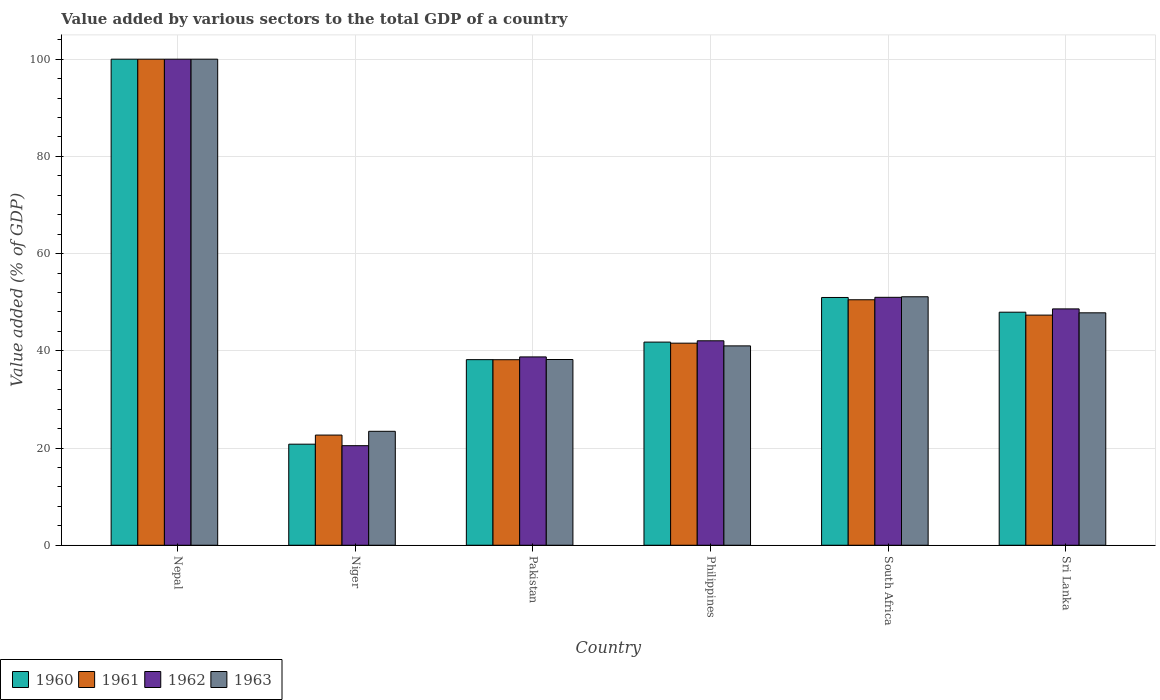What is the label of the 2nd group of bars from the left?
Your response must be concise. Niger. In how many cases, is the number of bars for a given country not equal to the number of legend labels?
Your answer should be very brief. 0. What is the value added by various sectors to the total GDP in 1961 in Philippines?
Offer a terse response. 41.57. Across all countries, what is the minimum value added by various sectors to the total GDP in 1962?
Make the answer very short. 20.48. In which country was the value added by various sectors to the total GDP in 1962 maximum?
Provide a succinct answer. Nepal. In which country was the value added by various sectors to the total GDP in 1960 minimum?
Your response must be concise. Niger. What is the total value added by various sectors to the total GDP in 1962 in the graph?
Provide a succinct answer. 300.92. What is the difference between the value added by various sectors to the total GDP in 1962 in South Africa and that in Sri Lanka?
Provide a succinct answer. 2.38. What is the difference between the value added by various sectors to the total GDP in 1963 in South Africa and the value added by various sectors to the total GDP in 1962 in Niger?
Ensure brevity in your answer.  30.63. What is the average value added by various sectors to the total GDP in 1961 per country?
Ensure brevity in your answer.  50.04. What is the difference between the value added by various sectors to the total GDP of/in 1963 and value added by various sectors to the total GDP of/in 1961 in Pakistan?
Your response must be concise. 0.04. In how many countries, is the value added by various sectors to the total GDP in 1963 greater than 40 %?
Offer a very short reply. 4. What is the ratio of the value added by various sectors to the total GDP in 1961 in Nepal to that in Pakistan?
Ensure brevity in your answer.  2.62. What is the difference between the highest and the second highest value added by various sectors to the total GDP in 1962?
Offer a terse response. -2.38. What is the difference between the highest and the lowest value added by various sectors to the total GDP in 1961?
Provide a succinct answer. 77.33. In how many countries, is the value added by various sectors to the total GDP in 1962 greater than the average value added by various sectors to the total GDP in 1962 taken over all countries?
Make the answer very short. 2. Is the sum of the value added by various sectors to the total GDP in 1963 in Niger and Pakistan greater than the maximum value added by various sectors to the total GDP in 1961 across all countries?
Make the answer very short. No. What does the 4th bar from the left in Niger represents?
Ensure brevity in your answer.  1963. Is it the case that in every country, the sum of the value added by various sectors to the total GDP in 1962 and value added by various sectors to the total GDP in 1963 is greater than the value added by various sectors to the total GDP in 1960?
Offer a terse response. Yes. How many countries are there in the graph?
Offer a terse response. 6. What is the difference between two consecutive major ticks on the Y-axis?
Offer a terse response. 20. Does the graph contain grids?
Make the answer very short. Yes. Where does the legend appear in the graph?
Your answer should be compact. Bottom left. How many legend labels are there?
Provide a succinct answer. 4. How are the legend labels stacked?
Your response must be concise. Horizontal. What is the title of the graph?
Offer a very short reply. Value added by various sectors to the total GDP of a country. Does "1963" appear as one of the legend labels in the graph?
Provide a succinct answer. Yes. What is the label or title of the X-axis?
Your answer should be very brief. Country. What is the label or title of the Y-axis?
Your answer should be compact. Value added (% of GDP). What is the Value added (% of GDP) of 1960 in Nepal?
Offer a very short reply. 100. What is the Value added (% of GDP) of 1962 in Nepal?
Your response must be concise. 100. What is the Value added (% of GDP) in 1963 in Nepal?
Your response must be concise. 100. What is the Value added (% of GDP) of 1960 in Niger?
Your answer should be compact. 20.79. What is the Value added (% of GDP) in 1961 in Niger?
Provide a succinct answer. 22.67. What is the Value added (% of GDP) in 1962 in Niger?
Provide a succinct answer. 20.48. What is the Value added (% of GDP) in 1963 in Niger?
Offer a very short reply. 23.44. What is the Value added (% of GDP) of 1960 in Pakistan?
Make the answer very short. 38.18. What is the Value added (% of GDP) of 1961 in Pakistan?
Your answer should be compact. 38.17. What is the Value added (% of GDP) in 1962 in Pakistan?
Your answer should be very brief. 38.74. What is the Value added (% of GDP) in 1963 in Pakistan?
Provide a short and direct response. 38.21. What is the Value added (% of GDP) in 1960 in Philippines?
Make the answer very short. 41.79. What is the Value added (% of GDP) in 1961 in Philippines?
Your answer should be compact. 41.57. What is the Value added (% of GDP) of 1962 in Philippines?
Provide a short and direct response. 42.06. What is the Value added (% of GDP) of 1963 in Philippines?
Keep it short and to the point. 41.01. What is the Value added (% of GDP) in 1960 in South Africa?
Make the answer very short. 50.97. What is the Value added (% of GDP) of 1961 in South Africa?
Give a very brief answer. 50.5. What is the Value added (% of GDP) in 1962 in South Africa?
Give a very brief answer. 51.01. What is the Value added (% of GDP) of 1963 in South Africa?
Your answer should be compact. 51.12. What is the Value added (% of GDP) in 1960 in Sri Lanka?
Provide a short and direct response. 47.95. What is the Value added (% of GDP) of 1961 in Sri Lanka?
Ensure brevity in your answer.  47.35. What is the Value added (% of GDP) in 1962 in Sri Lanka?
Your response must be concise. 48.62. What is the Value added (% of GDP) of 1963 in Sri Lanka?
Ensure brevity in your answer.  47.82. Across all countries, what is the minimum Value added (% of GDP) in 1960?
Your answer should be compact. 20.79. Across all countries, what is the minimum Value added (% of GDP) in 1961?
Offer a very short reply. 22.67. Across all countries, what is the minimum Value added (% of GDP) of 1962?
Provide a succinct answer. 20.48. Across all countries, what is the minimum Value added (% of GDP) of 1963?
Offer a terse response. 23.44. What is the total Value added (% of GDP) in 1960 in the graph?
Offer a very short reply. 299.68. What is the total Value added (% of GDP) of 1961 in the graph?
Ensure brevity in your answer.  300.26. What is the total Value added (% of GDP) of 1962 in the graph?
Give a very brief answer. 300.92. What is the total Value added (% of GDP) of 1963 in the graph?
Give a very brief answer. 301.6. What is the difference between the Value added (% of GDP) in 1960 in Nepal and that in Niger?
Give a very brief answer. 79.21. What is the difference between the Value added (% of GDP) in 1961 in Nepal and that in Niger?
Offer a terse response. 77.33. What is the difference between the Value added (% of GDP) of 1962 in Nepal and that in Niger?
Your response must be concise. 79.52. What is the difference between the Value added (% of GDP) of 1963 in Nepal and that in Niger?
Your answer should be compact. 76.56. What is the difference between the Value added (% of GDP) of 1960 in Nepal and that in Pakistan?
Provide a succinct answer. 61.82. What is the difference between the Value added (% of GDP) of 1961 in Nepal and that in Pakistan?
Offer a very short reply. 61.83. What is the difference between the Value added (% of GDP) in 1962 in Nepal and that in Pakistan?
Give a very brief answer. 61.26. What is the difference between the Value added (% of GDP) of 1963 in Nepal and that in Pakistan?
Your answer should be compact. 61.79. What is the difference between the Value added (% of GDP) of 1960 in Nepal and that in Philippines?
Offer a terse response. 58.21. What is the difference between the Value added (% of GDP) of 1961 in Nepal and that in Philippines?
Make the answer very short. 58.42. What is the difference between the Value added (% of GDP) in 1962 in Nepal and that in Philippines?
Provide a succinct answer. 57.94. What is the difference between the Value added (% of GDP) of 1963 in Nepal and that in Philippines?
Make the answer very short. 58.99. What is the difference between the Value added (% of GDP) of 1960 in Nepal and that in South Africa?
Your answer should be compact. 49.03. What is the difference between the Value added (% of GDP) of 1961 in Nepal and that in South Africa?
Your answer should be very brief. 49.5. What is the difference between the Value added (% of GDP) in 1962 in Nepal and that in South Africa?
Ensure brevity in your answer.  48.99. What is the difference between the Value added (% of GDP) in 1963 in Nepal and that in South Africa?
Keep it short and to the point. 48.88. What is the difference between the Value added (% of GDP) in 1960 in Nepal and that in Sri Lanka?
Provide a short and direct response. 52.05. What is the difference between the Value added (% of GDP) of 1961 in Nepal and that in Sri Lanka?
Your response must be concise. 52.65. What is the difference between the Value added (% of GDP) in 1962 in Nepal and that in Sri Lanka?
Your response must be concise. 51.38. What is the difference between the Value added (% of GDP) of 1963 in Nepal and that in Sri Lanka?
Give a very brief answer. 52.18. What is the difference between the Value added (% of GDP) of 1960 in Niger and that in Pakistan?
Offer a very short reply. -17.39. What is the difference between the Value added (% of GDP) of 1961 in Niger and that in Pakistan?
Your response must be concise. -15.5. What is the difference between the Value added (% of GDP) in 1962 in Niger and that in Pakistan?
Your answer should be very brief. -18.26. What is the difference between the Value added (% of GDP) of 1963 in Niger and that in Pakistan?
Your answer should be very brief. -14.77. What is the difference between the Value added (% of GDP) in 1960 in Niger and that in Philippines?
Offer a terse response. -21. What is the difference between the Value added (% of GDP) of 1961 in Niger and that in Philippines?
Make the answer very short. -18.91. What is the difference between the Value added (% of GDP) in 1962 in Niger and that in Philippines?
Provide a short and direct response. -21.58. What is the difference between the Value added (% of GDP) in 1963 in Niger and that in Philippines?
Your response must be concise. -17.58. What is the difference between the Value added (% of GDP) in 1960 in Niger and that in South Africa?
Provide a short and direct response. -30.18. What is the difference between the Value added (% of GDP) in 1961 in Niger and that in South Africa?
Make the answer very short. -27.84. What is the difference between the Value added (% of GDP) in 1962 in Niger and that in South Africa?
Keep it short and to the point. -30.52. What is the difference between the Value added (% of GDP) in 1963 in Niger and that in South Africa?
Your response must be concise. -27.68. What is the difference between the Value added (% of GDP) in 1960 in Niger and that in Sri Lanka?
Ensure brevity in your answer.  -27.16. What is the difference between the Value added (% of GDP) of 1961 in Niger and that in Sri Lanka?
Provide a succinct answer. -24.68. What is the difference between the Value added (% of GDP) in 1962 in Niger and that in Sri Lanka?
Offer a very short reply. -28.14. What is the difference between the Value added (% of GDP) in 1963 in Niger and that in Sri Lanka?
Your response must be concise. -24.38. What is the difference between the Value added (% of GDP) in 1960 in Pakistan and that in Philippines?
Keep it short and to the point. -3.61. What is the difference between the Value added (% of GDP) in 1961 in Pakistan and that in Philippines?
Your response must be concise. -3.41. What is the difference between the Value added (% of GDP) of 1962 in Pakistan and that in Philippines?
Give a very brief answer. -3.32. What is the difference between the Value added (% of GDP) of 1963 in Pakistan and that in Philippines?
Provide a succinct answer. -2.81. What is the difference between the Value added (% of GDP) in 1960 in Pakistan and that in South Africa?
Provide a short and direct response. -12.79. What is the difference between the Value added (% of GDP) of 1961 in Pakistan and that in South Africa?
Your answer should be very brief. -12.33. What is the difference between the Value added (% of GDP) in 1962 in Pakistan and that in South Africa?
Ensure brevity in your answer.  -12.26. What is the difference between the Value added (% of GDP) in 1963 in Pakistan and that in South Africa?
Provide a short and direct response. -12.91. What is the difference between the Value added (% of GDP) of 1960 in Pakistan and that in Sri Lanka?
Keep it short and to the point. -9.76. What is the difference between the Value added (% of GDP) of 1961 in Pakistan and that in Sri Lanka?
Your answer should be compact. -9.18. What is the difference between the Value added (% of GDP) of 1962 in Pakistan and that in Sri Lanka?
Give a very brief answer. -9.88. What is the difference between the Value added (% of GDP) in 1963 in Pakistan and that in Sri Lanka?
Your response must be concise. -9.61. What is the difference between the Value added (% of GDP) in 1960 in Philippines and that in South Africa?
Offer a very short reply. -9.18. What is the difference between the Value added (% of GDP) in 1961 in Philippines and that in South Africa?
Make the answer very short. -8.93. What is the difference between the Value added (% of GDP) in 1962 in Philippines and that in South Africa?
Offer a very short reply. -8.94. What is the difference between the Value added (% of GDP) of 1963 in Philippines and that in South Africa?
Provide a short and direct response. -10.1. What is the difference between the Value added (% of GDP) of 1960 in Philippines and that in Sri Lanka?
Provide a succinct answer. -6.15. What is the difference between the Value added (% of GDP) of 1961 in Philippines and that in Sri Lanka?
Give a very brief answer. -5.77. What is the difference between the Value added (% of GDP) of 1962 in Philippines and that in Sri Lanka?
Make the answer very short. -6.56. What is the difference between the Value added (% of GDP) of 1963 in Philippines and that in Sri Lanka?
Provide a succinct answer. -6.8. What is the difference between the Value added (% of GDP) of 1960 in South Africa and that in Sri Lanka?
Ensure brevity in your answer.  3.03. What is the difference between the Value added (% of GDP) of 1961 in South Africa and that in Sri Lanka?
Give a very brief answer. 3.16. What is the difference between the Value added (% of GDP) in 1962 in South Africa and that in Sri Lanka?
Keep it short and to the point. 2.38. What is the difference between the Value added (% of GDP) in 1963 in South Africa and that in Sri Lanka?
Your answer should be compact. 3.3. What is the difference between the Value added (% of GDP) in 1960 in Nepal and the Value added (% of GDP) in 1961 in Niger?
Give a very brief answer. 77.33. What is the difference between the Value added (% of GDP) of 1960 in Nepal and the Value added (% of GDP) of 1962 in Niger?
Offer a terse response. 79.52. What is the difference between the Value added (% of GDP) in 1960 in Nepal and the Value added (% of GDP) in 1963 in Niger?
Ensure brevity in your answer.  76.56. What is the difference between the Value added (% of GDP) in 1961 in Nepal and the Value added (% of GDP) in 1962 in Niger?
Provide a short and direct response. 79.52. What is the difference between the Value added (% of GDP) in 1961 in Nepal and the Value added (% of GDP) in 1963 in Niger?
Provide a short and direct response. 76.56. What is the difference between the Value added (% of GDP) in 1962 in Nepal and the Value added (% of GDP) in 1963 in Niger?
Give a very brief answer. 76.56. What is the difference between the Value added (% of GDP) of 1960 in Nepal and the Value added (% of GDP) of 1961 in Pakistan?
Offer a very short reply. 61.83. What is the difference between the Value added (% of GDP) in 1960 in Nepal and the Value added (% of GDP) in 1962 in Pakistan?
Offer a terse response. 61.26. What is the difference between the Value added (% of GDP) in 1960 in Nepal and the Value added (% of GDP) in 1963 in Pakistan?
Make the answer very short. 61.79. What is the difference between the Value added (% of GDP) in 1961 in Nepal and the Value added (% of GDP) in 1962 in Pakistan?
Ensure brevity in your answer.  61.26. What is the difference between the Value added (% of GDP) in 1961 in Nepal and the Value added (% of GDP) in 1963 in Pakistan?
Provide a short and direct response. 61.79. What is the difference between the Value added (% of GDP) of 1962 in Nepal and the Value added (% of GDP) of 1963 in Pakistan?
Your answer should be very brief. 61.79. What is the difference between the Value added (% of GDP) in 1960 in Nepal and the Value added (% of GDP) in 1961 in Philippines?
Provide a succinct answer. 58.42. What is the difference between the Value added (% of GDP) of 1960 in Nepal and the Value added (% of GDP) of 1962 in Philippines?
Make the answer very short. 57.94. What is the difference between the Value added (% of GDP) of 1960 in Nepal and the Value added (% of GDP) of 1963 in Philippines?
Your answer should be compact. 58.99. What is the difference between the Value added (% of GDP) of 1961 in Nepal and the Value added (% of GDP) of 1962 in Philippines?
Offer a very short reply. 57.94. What is the difference between the Value added (% of GDP) in 1961 in Nepal and the Value added (% of GDP) in 1963 in Philippines?
Offer a very short reply. 58.99. What is the difference between the Value added (% of GDP) in 1962 in Nepal and the Value added (% of GDP) in 1963 in Philippines?
Keep it short and to the point. 58.99. What is the difference between the Value added (% of GDP) in 1960 in Nepal and the Value added (% of GDP) in 1961 in South Africa?
Your answer should be compact. 49.5. What is the difference between the Value added (% of GDP) of 1960 in Nepal and the Value added (% of GDP) of 1962 in South Africa?
Make the answer very short. 48.99. What is the difference between the Value added (% of GDP) in 1960 in Nepal and the Value added (% of GDP) in 1963 in South Africa?
Your response must be concise. 48.88. What is the difference between the Value added (% of GDP) of 1961 in Nepal and the Value added (% of GDP) of 1962 in South Africa?
Offer a very short reply. 48.99. What is the difference between the Value added (% of GDP) of 1961 in Nepal and the Value added (% of GDP) of 1963 in South Africa?
Make the answer very short. 48.88. What is the difference between the Value added (% of GDP) of 1962 in Nepal and the Value added (% of GDP) of 1963 in South Africa?
Give a very brief answer. 48.88. What is the difference between the Value added (% of GDP) of 1960 in Nepal and the Value added (% of GDP) of 1961 in Sri Lanka?
Your answer should be compact. 52.65. What is the difference between the Value added (% of GDP) in 1960 in Nepal and the Value added (% of GDP) in 1962 in Sri Lanka?
Your answer should be very brief. 51.38. What is the difference between the Value added (% of GDP) in 1960 in Nepal and the Value added (% of GDP) in 1963 in Sri Lanka?
Your answer should be compact. 52.18. What is the difference between the Value added (% of GDP) in 1961 in Nepal and the Value added (% of GDP) in 1962 in Sri Lanka?
Provide a short and direct response. 51.38. What is the difference between the Value added (% of GDP) of 1961 in Nepal and the Value added (% of GDP) of 1963 in Sri Lanka?
Provide a short and direct response. 52.18. What is the difference between the Value added (% of GDP) of 1962 in Nepal and the Value added (% of GDP) of 1963 in Sri Lanka?
Make the answer very short. 52.18. What is the difference between the Value added (% of GDP) of 1960 in Niger and the Value added (% of GDP) of 1961 in Pakistan?
Provide a succinct answer. -17.38. What is the difference between the Value added (% of GDP) of 1960 in Niger and the Value added (% of GDP) of 1962 in Pakistan?
Provide a succinct answer. -17.95. What is the difference between the Value added (% of GDP) in 1960 in Niger and the Value added (% of GDP) in 1963 in Pakistan?
Offer a very short reply. -17.42. What is the difference between the Value added (% of GDP) in 1961 in Niger and the Value added (% of GDP) in 1962 in Pakistan?
Provide a short and direct response. -16.08. What is the difference between the Value added (% of GDP) of 1961 in Niger and the Value added (% of GDP) of 1963 in Pakistan?
Keep it short and to the point. -15.54. What is the difference between the Value added (% of GDP) in 1962 in Niger and the Value added (% of GDP) in 1963 in Pakistan?
Provide a short and direct response. -17.73. What is the difference between the Value added (% of GDP) of 1960 in Niger and the Value added (% of GDP) of 1961 in Philippines?
Keep it short and to the point. -20.78. What is the difference between the Value added (% of GDP) of 1960 in Niger and the Value added (% of GDP) of 1962 in Philippines?
Offer a terse response. -21.27. What is the difference between the Value added (% of GDP) in 1960 in Niger and the Value added (% of GDP) in 1963 in Philippines?
Give a very brief answer. -20.22. What is the difference between the Value added (% of GDP) of 1961 in Niger and the Value added (% of GDP) of 1962 in Philippines?
Ensure brevity in your answer.  -19.4. What is the difference between the Value added (% of GDP) of 1961 in Niger and the Value added (% of GDP) of 1963 in Philippines?
Ensure brevity in your answer.  -18.35. What is the difference between the Value added (% of GDP) in 1962 in Niger and the Value added (% of GDP) in 1963 in Philippines?
Provide a succinct answer. -20.53. What is the difference between the Value added (% of GDP) of 1960 in Niger and the Value added (% of GDP) of 1961 in South Africa?
Offer a very short reply. -29.71. What is the difference between the Value added (% of GDP) in 1960 in Niger and the Value added (% of GDP) in 1962 in South Africa?
Your answer should be very brief. -30.22. What is the difference between the Value added (% of GDP) of 1960 in Niger and the Value added (% of GDP) of 1963 in South Africa?
Ensure brevity in your answer.  -30.33. What is the difference between the Value added (% of GDP) in 1961 in Niger and the Value added (% of GDP) in 1962 in South Africa?
Offer a terse response. -28.34. What is the difference between the Value added (% of GDP) of 1961 in Niger and the Value added (% of GDP) of 1963 in South Africa?
Your response must be concise. -28.45. What is the difference between the Value added (% of GDP) in 1962 in Niger and the Value added (% of GDP) in 1963 in South Africa?
Your response must be concise. -30.63. What is the difference between the Value added (% of GDP) in 1960 in Niger and the Value added (% of GDP) in 1961 in Sri Lanka?
Give a very brief answer. -26.56. What is the difference between the Value added (% of GDP) of 1960 in Niger and the Value added (% of GDP) of 1962 in Sri Lanka?
Your answer should be compact. -27.83. What is the difference between the Value added (% of GDP) of 1960 in Niger and the Value added (% of GDP) of 1963 in Sri Lanka?
Provide a succinct answer. -27.03. What is the difference between the Value added (% of GDP) in 1961 in Niger and the Value added (% of GDP) in 1962 in Sri Lanka?
Ensure brevity in your answer.  -25.96. What is the difference between the Value added (% of GDP) of 1961 in Niger and the Value added (% of GDP) of 1963 in Sri Lanka?
Your response must be concise. -25.15. What is the difference between the Value added (% of GDP) of 1962 in Niger and the Value added (% of GDP) of 1963 in Sri Lanka?
Your response must be concise. -27.33. What is the difference between the Value added (% of GDP) in 1960 in Pakistan and the Value added (% of GDP) in 1961 in Philippines?
Make the answer very short. -3.39. What is the difference between the Value added (% of GDP) in 1960 in Pakistan and the Value added (% of GDP) in 1962 in Philippines?
Your answer should be very brief. -3.88. What is the difference between the Value added (% of GDP) of 1960 in Pakistan and the Value added (% of GDP) of 1963 in Philippines?
Your answer should be compact. -2.83. What is the difference between the Value added (% of GDP) in 1961 in Pakistan and the Value added (% of GDP) in 1962 in Philippines?
Your answer should be compact. -3.89. What is the difference between the Value added (% of GDP) of 1961 in Pakistan and the Value added (% of GDP) of 1963 in Philippines?
Keep it short and to the point. -2.85. What is the difference between the Value added (% of GDP) in 1962 in Pakistan and the Value added (% of GDP) in 1963 in Philippines?
Keep it short and to the point. -2.27. What is the difference between the Value added (% of GDP) of 1960 in Pakistan and the Value added (% of GDP) of 1961 in South Africa?
Your answer should be compact. -12.32. What is the difference between the Value added (% of GDP) of 1960 in Pakistan and the Value added (% of GDP) of 1962 in South Africa?
Offer a very short reply. -12.82. What is the difference between the Value added (% of GDP) of 1960 in Pakistan and the Value added (% of GDP) of 1963 in South Africa?
Give a very brief answer. -12.93. What is the difference between the Value added (% of GDP) in 1961 in Pakistan and the Value added (% of GDP) in 1962 in South Africa?
Make the answer very short. -12.84. What is the difference between the Value added (% of GDP) of 1961 in Pakistan and the Value added (% of GDP) of 1963 in South Africa?
Offer a terse response. -12.95. What is the difference between the Value added (% of GDP) of 1962 in Pakistan and the Value added (% of GDP) of 1963 in South Africa?
Your answer should be compact. -12.37. What is the difference between the Value added (% of GDP) of 1960 in Pakistan and the Value added (% of GDP) of 1961 in Sri Lanka?
Your response must be concise. -9.16. What is the difference between the Value added (% of GDP) in 1960 in Pakistan and the Value added (% of GDP) in 1962 in Sri Lanka?
Offer a very short reply. -10.44. What is the difference between the Value added (% of GDP) of 1960 in Pakistan and the Value added (% of GDP) of 1963 in Sri Lanka?
Offer a terse response. -9.63. What is the difference between the Value added (% of GDP) in 1961 in Pakistan and the Value added (% of GDP) in 1962 in Sri Lanka?
Make the answer very short. -10.46. What is the difference between the Value added (% of GDP) of 1961 in Pakistan and the Value added (% of GDP) of 1963 in Sri Lanka?
Give a very brief answer. -9.65. What is the difference between the Value added (% of GDP) of 1962 in Pakistan and the Value added (% of GDP) of 1963 in Sri Lanka?
Your response must be concise. -9.07. What is the difference between the Value added (% of GDP) of 1960 in Philippines and the Value added (% of GDP) of 1961 in South Africa?
Your response must be concise. -8.71. What is the difference between the Value added (% of GDP) of 1960 in Philippines and the Value added (% of GDP) of 1962 in South Africa?
Give a very brief answer. -9.21. What is the difference between the Value added (% of GDP) of 1960 in Philippines and the Value added (% of GDP) of 1963 in South Africa?
Offer a very short reply. -9.33. What is the difference between the Value added (% of GDP) of 1961 in Philippines and the Value added (% of GDP) of 1962 in South Africa?
Ensure brevity in your answer.  -9.43. What is the difference between the Value added (% of GDP) of 1961 in Philippines and the Value added (% of GDP) of 1963 in South Africa?
Make the answer very short. -9.54. What is the difference between the Value added (% of GDP) of 1962 in Philippines and the Value added (% of GDP) of 1963 in South Africa?
Give a very brief answer. -9.05. What is the difference between the Value added (% of GDP) of 1960 in Philippines and the Value added (% of GDP) of 1961 in Sri Lanka?
Offer a very short reply. -5.55. What is the difference between the Value added (% of GDP) in 1960 in Philippines and the Value added (% of GDP) in 1962 in Sri Lanka?
Provide a succinct answer. -6.83. What is the difference between the Value added (% of GDP) of 1960 in Philippines and the Value added (% of GDP) of 1963 in Sri Lanka?
Your response must be concise. -6.03. What is the difference between the Value added (% of GDP) of 1961 in Philippines and the Value added (% of GDP) of 1962 in Sri Lanka?
Provide a short and direct response. -7.05. What is the difference between the Value added (% of GDP) of 1961 in Philippines and the Value added (% of GDP) of 1963 in Sri Lanka?
Give a very brief answer. -6.24. What is the difference between the Value added (% of GDP) of 1962 in Philippines and the Value added (% of GDP) of 1963 in Sri Lanka?
Your response must be concise. -5.75. What is the difference between the Value added (% of GDP) in 1960 in South Africa and the Value added (% of GDP) in 1961 in Sri Lanka?
Make the answer very short. 3.63. What is the difference between the Value added (% of GDP) in 1960 in South Africa and the Value added (% of GDP) in 1962 in Sri Lanka?
Make the answer very short. 2.35. What is the difference between the Value added (% of GDP) of 1960 in South Africa and the Value added (% of GDP) of 1963 in Sri Lanka?
Offer a terse response. 3.16. What is the difference between the Value added (% of GDP) in 1961 in South Africa and the Value added (% of GDP) in 1962 in Sri Lanka?
Provide a succinct answer. 1.88. What is the difference between the Value added (% of GDP) in 1961 in South Africa and the Value added (% of GDP) in 1963 in Sri Lanka?
Your answer should be compact. 2.69. What is the difference between the Value added (% of GDP) in 1962 in South Africa and the Value added (% of GDP) in 1963 in Sri Lanka?
Make the answer very short. 3.19. What is the average Value added (% of GDP) of 1960 per country?
Give a very brief answer. 49.95. What is the average Value added (% of GDP) of 1961 per country?
Offer a very short reply. 50.04. What is the average Value added (% of GDP) of 1962 per country?
Provide a succinct answer. 50.15. What is the average Value added (% of GDP) of 1963 per country?
Your response must be concise. 50.27. What is the difference between the Value added (% of GDP) in 1960 and Value added (% of GDP) in 1961 in Nepal?
Offer a very short reply. 0. What is the difference between the Value added (% of GDP) of 1960 and Value added (% of GDP) of 1962 in Nepal?
Offer a terse response. 0. What is the difference between the Value added (% of GDP) of 1961 and Value added (% of GDP) of 1962 in Nepal?
Offer a terse response. 0. What is the difference between the Value added (% of GDP) of 1962 and Value added (% of GDP) of 1963 in Nepal?
Offer a very short reply. 0. What is the difference between the Value added (% of GDP) in 1960 and Value added (% of GDP) in 1961 in Niger?
Your answer should be very brief. -1.88. What is the difference between the Value added (% of GDP) in 1960 and Value added (% of GDP) in 1962 in Niger?
Provide a short and direct response. 0.31. What is the difference between the Value added (% of GDP) of 1960 and Value added (% of GDP) of 1963 in Niger?
Ensure brevity in your answer.  -2.65. What is the difference between the Value added (% of GDP) of 1961 and Value added (% of GDP) of 1962 in Niger?
Provide a succinct answer. 2.18. What is the difference between the Value added (% of GDP) in 1961 and Value added (% of GDP) in 1963 in Niger?
Provide a succinct answer. -0.77. What is the difference between the Value added (% of GDP) in 1962 and Value added (% of GDP) in 1963 in Niger?
Give a very brief answer. -2.96. What is the difference between the Value added (% of GDP) of 1960 and Value added (% of GDP) of 1961 in Pakistan?
Offer a very short reply. 0.01. What is the difference between the Value added (% of GDP) of 1960 and Value added (% of GDP) of 1962 in Pakistan?
Your answer should be very brief. -0.56. What is the difference between the Value added (% of GDP) in 1960 and Value added (% of GDP) in 1963 in Pakistan?
Keep it short and to the point. -0.03. What is the difference between the Value added (% of GDP) in 1961 and Value added (% of GDP) in 1962 in Pakistan?
Ensure brevity in your answer.  -0.58. What is the difference between the Value added (% of GDP) in 1961 and Value added (% of GDP) in 1963 in Pakistan?
Provide a short and direct response. -0.04. What is the difference between the Value added (% of GDP) in 1962 and Value added (% of GDP) in 1963 in Pakistan?
Keep it short and to the point. 0.53. What is the difference between the Value added (% of GDP) in 1960 and Value added (% of GDP) in 1961 in Philippines?
Your answer should be very brief. 0.22. What is the difference between the Value added (% of GDP) in 1960 and Value added (% of GDP) in 1962 in Philippines?
Provide a short and direct response. -0.27. What is the difference between the Value added (% of GDP) in 1960 and Value added (% of GDP) in 1963 in Philippines?
Make the answer very short. 0.78. What is the difference between the Value added (% of GDP) in 1961 and Value added (% of GDP) in 1962 in Philippines?
Keep it short and to the point. -0.49. What is the difference between the Value added (% of GDP) in 1961 and Value added (% of GDP) in 1963 in Philippines?
Your answer should be very brief. 0.56. What is the difference between the Value added (% of GDP) in 1962 and Value added (% of GDP) in 1963 in Philippines?
Offer a very short reply. 1.05. What is the difference between the Value added (% of GDP) in 1960 and Value added (% of GDP) in 1961 in South Africa?
Offer a very short reply. 0.47. What is the difference between the Value added (% of GDP) of 1960 and Value added (% of GDP) of 1962 in South Africa?
Provide a succinct answer. -0.03. What is the difference between the Value added (% of GDP) of 1960 and Value added (% of GDP) of 1963 in South Africa?
Offer a very short reply. -0.15. What is the difference between the Value added (% of GDP) of 1961 and Value added (% of GDP) of 1962 in South Africa?
Provide a short and direct response. -0.5. What is the difference between the Value added (% of GDP) of 1961 and Value added (% of GDP) of 1963 in South Africa?
Offer a terse response. -0.61. What is the difference between the Value added (% of GDP) of 1962 and Value added (% of GDP) of 1963 in South Africa?
Provide a succinct answer. -0.11. What is the difference between the Value added (% of GDP) of 1960 and Value added (% of GDP) of 1961 in Sri Lanka?
Offer a very short reply. 0.6. What is the difference between the Value added (% of GDP) in 1960 and Value added (% of GDP) in 1962 in Sri Lanka?
Your answer should be compact. -0.68. What is the difference between the Value added (% of GDP) of 1960 and Value added (% of GDP) of 1963 in Sri Lanka?
Make the answer very short. 0.13. What is the difference between the Value added (% of GDP) in 1961 and Value added (% of GDP) in 1962 in Sri Lanka?
Ensure brevity in your answer.  -1.28. What is the difference between the Value added (% of GDP) of 1961 and Value added (% of GDP) of 1963 in Sri Lanka?
Give a very brief answer. -0.47. What is the difference between the Value added (% of GDP) of 1962 and Value added (% of GDP) of 1963 in Sri Lanka?
Ensure brevity in your answer.  0.81. What is the ratio of the Value added (% of GDP) in 1960 in Nepal to that in Niger?
Ensure brevity in your answer.  4.81. What is the ratio of the Value added (% of GDP) in 1961 in Nepal to that in Niger?
Ensure brevity in your answer.  4.41. What is the ratio of the Value added (% of GDP) of 1962 in Nepal to that in Niger?
Your response must be concise. 4.88. What is the ratio of the Value added (% of GDP) of 1963 in Nepal to that in Niger?
Your answer should be compact. 4.27. What is the ratio of the Value added (% of GDP) in 1960 in Nepal to that in Pakistan?
Ensure brevity in your answer.  2.62. What is the ratio of the Value added (% of GDP) of 1961 in Nepal to that in Pakistan?
Your answer should be very brief. 2.62. What is the ratio of the Value added (% of GDP) of 1962 in Nepal to that in Pakistan?
Offer a very short reply. 2.58. What is the ratio of the Value added (% of GDP) in 1963 in Nepal to that in Pakistan?
Offer a terse response. 2.62. What is the ratio of the Value added (% of GDP) of 1960 in Nepal to that in Philippines?
Make the answer very short. 2.39. What is the ratio of the Value added (% of GDP) of 1961 in Nepal to that in Philippines?
Give a very brief answer. 2.41. What is the ratio of the Value added (% of GDP) in 1962 in Nepal to that in Philippines?
Offer a very short reply. 2.38. What is the ratio of the Value added (% of GDP) of 1963 in Nepal to that in Philippines?
Your answer should be very brief. 2.44. What is the ratio of the Value added (% of GDP) of 1960 in Nepal to that in South Africa?
Make the answer very short. 1.96. What is the ratio of the Value added (% of GDP) in 1961 in Nepal to that in South Africa?
Ensure brevity in your answer.  1.98. What is the ratio of the Value added (% of GDP) of 1962 in Nepal to that in South Africa?
Provide a succinct answer. 1.96. What is the ratio of the Value added (% of GDP) in 1963 in Nepal to that in South Africa?
Make the answer very short. 1.96. What is the ratio of the Value added (% of GDP) of 1960 in Nepal to that in Sri Lanka?
Provide a succinct answer. 2.09. What is the ratio of the Value added (% of GDP) in 1961 in Nepal to that in Sri Lanka?
Keep it short and to the point. 2.11. What is the ratio of the Value added (% of GDP) in 1962 in Nepal to that in Sri Lanka?
Provide a short and direct response. 2.06. What is the ratio of the Value added (% of GDP) in 1963 in Nepal to that in Sri Lanka?
Ensure brevity in your answer.  2.09. What is the ratio of the Value added (% of GDP) of 1960 in Niger to that in Pakistan?
Your response must be concise. 0.54. What is the ratio of the Value added (% of GDP) in 1961 in Niger to that in Pakistan?
Ensure brevity in your answer.  0.59. What is the ratio of the Value added (% of GDP) of 1962 in Niger to that in Pakistan?
Give a very brief answer. 0.53. What is the ratio of the Value added (% of GDP) of 1963 in Niger to that in Pakistan?
Your response must be concise. 0.61. What is the ratio of the Value added (% of GDP) in 1960 in Niger to that in Philippines?
Provide a succinct answer. 0.5. What is the ratio of the Value added (% of GDP) in 1961 in Niger to that in Philippines?
Offer a very short reply. 0.55. What is the ratio of the Value added (% of GDP) of 1962 in Niger to that in Philippines?
Your answer should be compact. 0.49. What is the ratio of the Value added (% of GDP) of 1963 in Niger to that in Philippines?
Keep it short and to the point. 0.57. What is the ratio of the Value added (% of GDP) in 1960 in Niger to that in South Africa?
Provide a succinct answer. 0.41. What is the ratio of the Value added (% of GDP) in 1961 in Niger to that in South Africa?
Provide a succinct answer. 0.45. What is the ratio of the Value added (% of GDP) in 1962 in Niger to that in South Africa?
Offer a very short reply. 0.4. What is the ratio of the Value added (% of GDP) of 1963 in Niger to that in South Africa?
Offer a very short reply. 0.46. What is the ratio of the Value added (% of GDP) in 1960 in Niger to that in Sri Lanka?
Ensure brevity in your answer.  0.43. What is the ratio of the Value added (% of GDP) of 1961 in Niger to that in Sri Lanka?
Offer a very short reply. 0.48. What is the ratio of the Value added (% of GDP) of 1962 in Niger to that in Sri Lanka?
Make the answer very short. 0.42. What is the ratio of the Value added (% of GDP) of 1963 in Niger to that in Sri Lanka?
Offer a very short reply. 0.49. What is the ratio of the Value added (% of GDP) of 1960 in Pakistan to that in Philippines?
Provide a succinct answer. 0.91. What is the ratio of the Value added (% of GDP) of 1961 in Pakistan to that in Philippines?
Offer a terse response. 0.92. What is the ratio of the Value added (% of GDP) of 1962 in Pakistan to that in Philippines?
Ensure brevity in your answer.  0.92. What is the ratio of the Value added (% of GDP) in 1963 in Pakistan to that in Philippines?
Your response must be concise. 0.93. What is the ratio of the Value added (% of GDP) of 1960 in Pakistan to that in South Africa?
Give a very brief answer. 0.75. What is the ratio of the Value added (% of GDP) of 1961 in Pakistan to that in South Africa?
Offer a terse response. 0.76. What is the ratio of the Value added (% of GDP) in 1962 in Pakistan to that in South Africa?
Your answer should be very brief. 0.76. What is the ratio of the Value added (% of GDP) in 1963 in Pakistan to that in South Africa?
Your response must be concise. 0.75. What is the ratio of the Value added (% of GDP) in 1960 in Pakistan to that in Sri Lanka?
Provide a succinct answer. 0.8. What is the ratio of the Value added (% of GDP) of 1961 in Pakistan to that in Sri Lanka?
Make the answer very short. 0.81. What is the ratio of the Value added (% of GDP) in 1962 in Pakistan to that in Sri Lanka?
Make the answer very short. 0.8. What is the ratio of the Value added (% of GDP) in 1963 in Pakistan to that in Sri Lanka?
Make the answer very short. 0.8. What is the ratio of the Value added (% of GDP) of 1960 in Philippines to that in South Africa?
Provide a short and direct response. 0.82. What is the ratio of the Value added (% of GDP) of 1961 in Philippines to that in South Africa?
Your response must be concise. 0.82. What is the ratio of the Value added (% of GDP) in 1962 in Philippines to that in South Africa?
Give a very brief answer. 0.82. What is the ratio of the Value added (% of GDP) of 1963 in Philippines to that in South Africa?
Ensure brevity in your answer.  0.8. What is the ratio of the Value added (% of GDP) of 1960 in Philippines to that in Sri Lanka?
Keep it short and to the point. 0.87. What is the ratio of the Value added (% of GDP) in 1961 in Philippines to that in Sri Lanka?
Offer a very short reply. 0.88. What is the ratio of the Value added (% of GDP) of 1962 in Philippines to that in Sri Lanka?
Provide a succinct answer. 0.87. What is the ratio of the Value added (% of GDP) of 1963 in Philippines to that in Sri Lanka?
Your answer should be very brief. 0.86. What is the ratio of the Value added (% of GDP) in 1960 in South Africa to that in Sri Lanka?
Ensure brevity in your answer.  1.06. What is the ratio of the Value added (% of GDP) of 1961 in South Africa to that in Sri Lanka?
Offer a terse response. 1.07. What is the ratio of the Value added (% of GDP) in 1962 in South Africa to that in Sri Lanka?
Offer a terse response. 1.05. What is the ratio of the Value added (% of GDP) in 1963 in South Africa to that in Sri Lanka?
Ensure brevity in your answer.  1.07. What is the difference between the highest and the second highest Value added (% of GDP) in 1960?
Provide a succinct answer. 49.03. What is the difference between the highest and the second highest Value added (% of GDP) in 1961?
Give a very brief answer. 49.5. What is the difference between the highest and the second highest Value added (% of GDP) of 1962?
Give a very brief answer. 48.99. What is the difference between the highest and the second highest Value added (% of GDP) of 1963?
Keep it short and to the point. 48.88. What is the difference between the highest and the lowest Value added (% of GDP) of 1960?
Provide a succinct answer. 79.21. What is the difference between the highest and the lowest Value added (% of GDP) in 1961?
Your answer should be very brief. 77.33. What is the difference between the highest and the lowest Value added (% of GDP) in 1962?
Offer a terse response. 79.52. What is the difference between the highest and the lowest Value added (% of GDP) of 1963?
Make the answer very short. 76.56. 